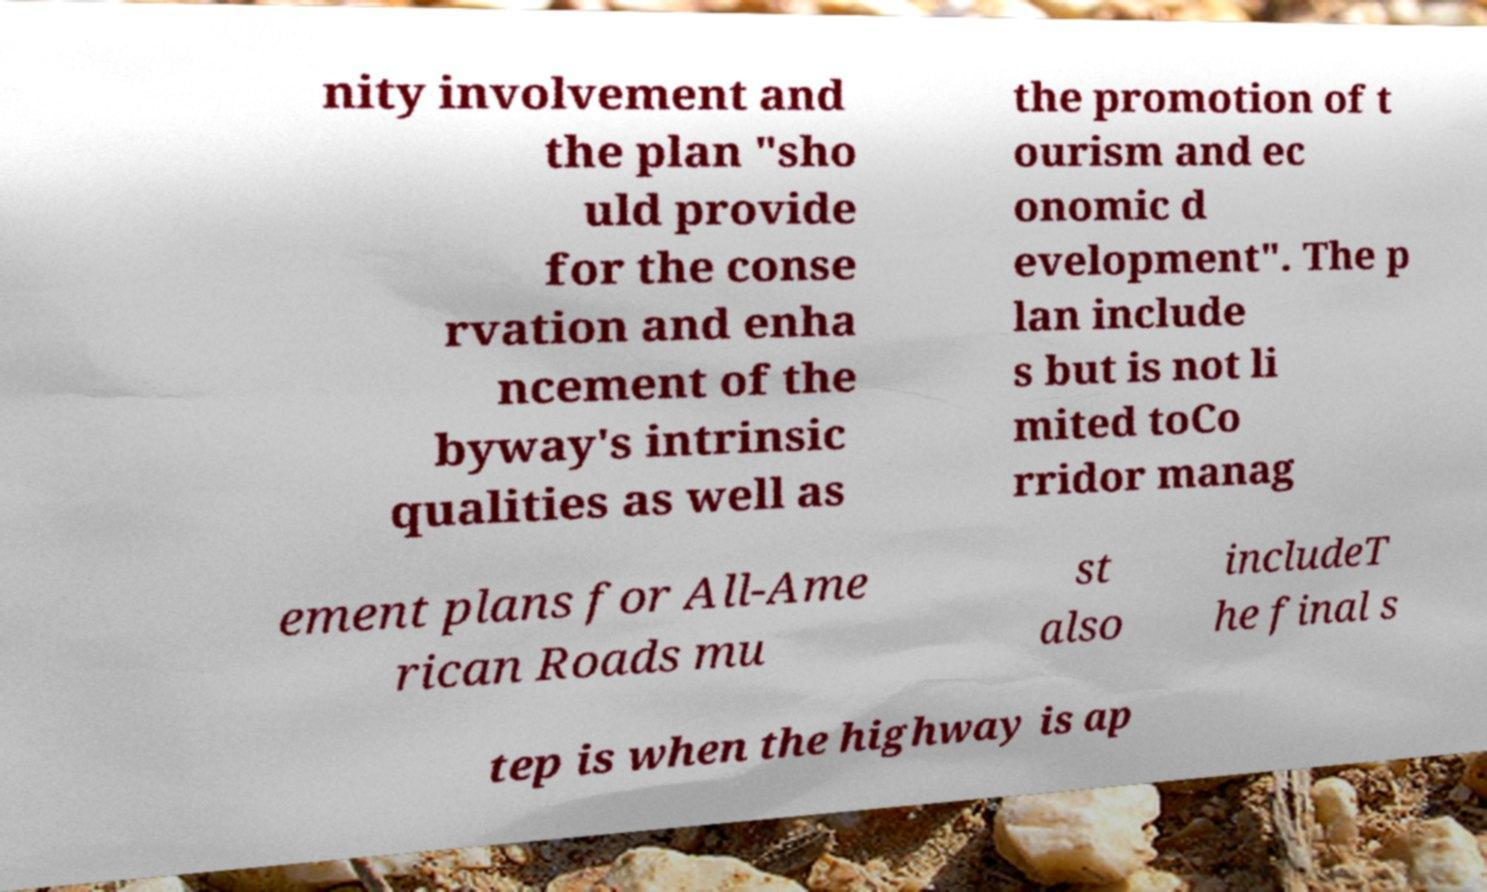Could you extract and type out the text from this image? nity involvement and the plan "sho uld provide for the conse rvation and enha ncement of the byway's intrinsic qualities as well as the promotion of t ourism and ec onomic d evelopment". The p lan include s but is not li mited toCo rridor manag ement plans for All-Ame rican Roads mu st also includeT he final s tep is when the highway is ap 